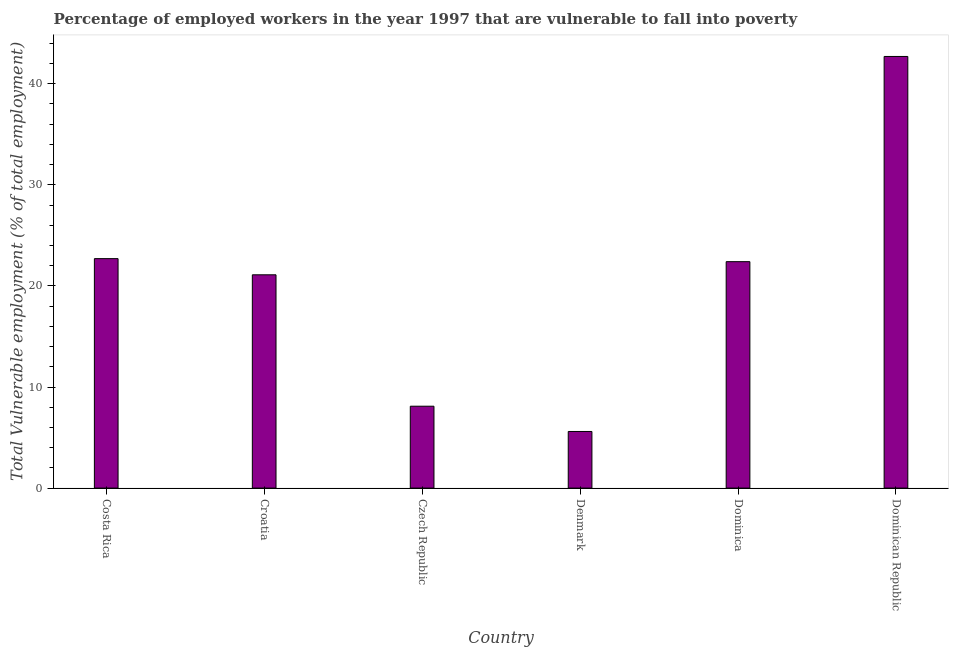Does the graph contain any zero values?
Provide a short and direct response. No. Does the graph contain grids?
Ensure brevity in your answer.  No. What is the title of the graph?
Ensure brevity in your answer.  Percentage of employed workers in the year 1997 that are vulnerable to fall into poverty. What is the label or title of the Y-axis?
Ensure brevity in your answer.  Total Vulnerable employment (% of total employment). What is the total vulnerable employment in Dominican Republic?
Give a very brief answer. 42.7. Across all countries, what is the maximum total vulnerable employment?
Keep it short and to the point. 42.7. Across all countries, what is the minimum total vulnerable employment?
Offer a very short reply. 5.6. In which country was the total vulnerable employment maximum?
Give a very brief answer. Dominican Republic. What is the sum of the total vulnerable employment?
Give a very brief answer. 122.6. What is the average total vulnerable employment per country?
Offer a terse response. 20.43. What is the median total vulnerable employment?
Provide a succinct answer. 21.75. In how many countries, is the total vulnerable employment greater than 12 %?
Your answer should be compact. 4. What is the ratio of the total vulnerable employment in Denmark to that in Dominican Republic?
Offer a very short reply. 0.13. Is the difference between the total vulnerable employment in Croatia and Dominican Republic greater than the difference between any two countries?
Give a very brief answer. No. What is the difference between the highest and the second highest total vulnerable employment?
Offer a terse response. 20. What is the difference between the highest and the lowest total vulnerable employment?
Provide a succinct answer. 37.1. How many bars are there?
Ensure brevity in your answer.  6. How many countries are there in the graph?
Your response must be concise. 6. What is the difference between two consecutive major ticks on the Y-axis?
Ensure brevity in your answer.  10. What is the Total Vulnerable employment (% of total employment) in Costa Rica?
Keep it short and to the point. 22.7. What is the Total Vulnerable employment (% of total employment) of Croatia?
Make the answer very short. 21.1. What is the Total Vulnerable employment (% of total employment) of Czech Republic?
Offer a very short reply. 8.1. What is the Total Vulnerable employment (% of total employment) in Denmark?
Your response must be concise. 5.6. What is the Total Vulnerable employment (% of total employment) in Dominica?
Give a very brief answer. 22.4. What is the Total Vulnerable employment (% of total employment) of Dominican Republic?
Provide a succinct answer. 42.7. What is the difference between the Total Vulnerable employment (% of total employment) in Costa Rica and Denmark?
Keep it short and to the point. 17.1. What is the difference between the Total Vulnerable employment (% of total employment) in Costa Rica and Dominica?
Offer a terse response. 0.3. What is the difference between the Total Vulnerable employment (% of total employment) in Costa Rica and Dominican Republic?
Your response must be concise. -20. What is the difference between the Total Vulnerable employment (% of total employment) in Croatia and Denmark?
Your answer should be very brief. 15.5. What is the difference between the Total Vulnerable employment (% of total employment) in Croatia and Dominica?
Keep it short and to the point. -1.3. What is the difference between the Total Vulnerable employment (% of total employment) in Croatia and Dominican Republic?
Offer a terse response. -21.6. What is the difference between the Total Vulnerable employment (% of total employment) in Czech Republic and Dominica?
Your answer should be compact. -14.3. What is the difference between the Total Vulnerable employment (% of total employment) in Czech Republic and Dominican Republic?
Ensure brevity in your answer.  -34.6. What is the difference between the Total Vulnerable employment (% of total employment) in Denmark and Dominica?
Offer a terse response. -16.8. What is the difference between the Total Vulnerable employment (% of total employment) in Denmark and Dominican Republic?
Provide a short and direct response. -37.1. What is the difference between the Total Vulnerable employment (% of total employment) in Dominica and Dominican Republic?
Offer a terse response. -20.3. What is the ratio of the Total Vulnerable employment (% of total employment) in Costa Rica to that in Croatia?
Provide a short and direct response. 1.08. What is the ratio of the Total Vulnerable employment (% of total employment) in Costa Rica to that in Czech Republic?
Your answer should be compact. 2.8. What is the ratio of the Total Vulnerable employment (% of total employment) in Costa Rica to that in Denmark?
Keep it short and to the point. 4.05. What is the ratio of the Total Vulnerable employment (% of total employment) in Costa Rica to that in Dominica?
Give a very brief answer. 1.01. What is the ratio of the Total Vulnerable employment (% of total employment) in Costa Rica to that in Dominican Republic?
Ensure brevity in your answer.  0.53. What is the ratio of the Total Vulnerable employment (% of total employment) in Croatia to that in Czech Republic?
Keep it short and to the point. 2.6. What is the ratio of the Total Vulnerable employment (% of total employment) in Croatia to that in Denmark?
Your answer should be very brief. 3.77. What is the ratio of the Total Vulnerable employment (% of total employment) in Croatia to that in Dominica?
Keep it short and to the point. 0.94. What is the ratio of the Total Vulnerable employment (% of total employment) in Croatia to that in Dominican Republic?
Make the answer very short. 0.49. What is the ratio of the Total Vulnerable employment (% of total employment) in Czech Republic to that in Denmark?
Your answer should be compact. 1.45. What is the ratio of the Total Vulnerable employment (% of total employment) in Czech Republic to that in Dominica?
Make the answer very short. 0.36. What is the ratio of the Total Vulnerable employment (% of total employment) in Czech Republic to that in Dominican Republic?
Give a very brief answer. 0.19. What is the ratio of the Total Vulnerable employment (% of total employment) in Denmark to that in Dominican Republic?
Keep it short and to the point. 0.13. What is the ratio of the Total Vulnerable employment (% of total employment) in Dominica to that in Dominican Republic?
Make the answer very short. 0.53. 